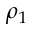Convert formula to latex. <formula><loc_0><loc_0><loc_500><loc_500>\rho _ { 1 }</formula> 